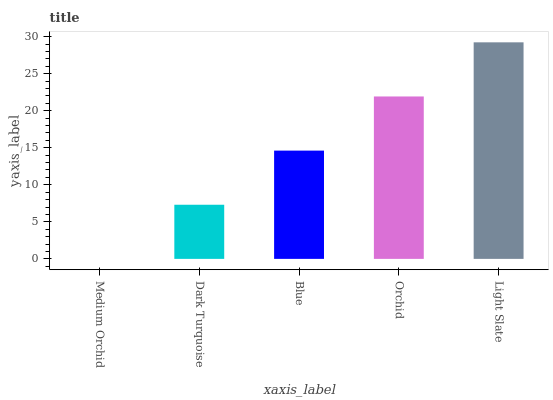Is Medium Orchid the minimum?
Answer yes or no. Yes. Is Light Slate the maximum?
Answer yes or no. Yes. Is Dark Turquoise the minimum?
Answer yes or no. No. Is Dark Turquoise the maximum?
Answer yes or no. No. Is Dark Turquoise greater than Medium Orchid?
Answer yes or no. Yes. Is Medium Orchid less than Dark Turquoise?
Answer yes or no. Yes. Is Medium Orchid greater than Dark Turquoise?
Answer yes or no. No. Is Dark Turquoise less than Medium Orchid?
Answer yes or no. No. Is Blue the high median?
Answer yes or no. Yes. Is Blue the low median?
Answer yes or no. Yes. Is Medium Orchid the high median?
Answer yes or no. No. Is Dark Turquoise the low median?
Answer yes or no. No. 